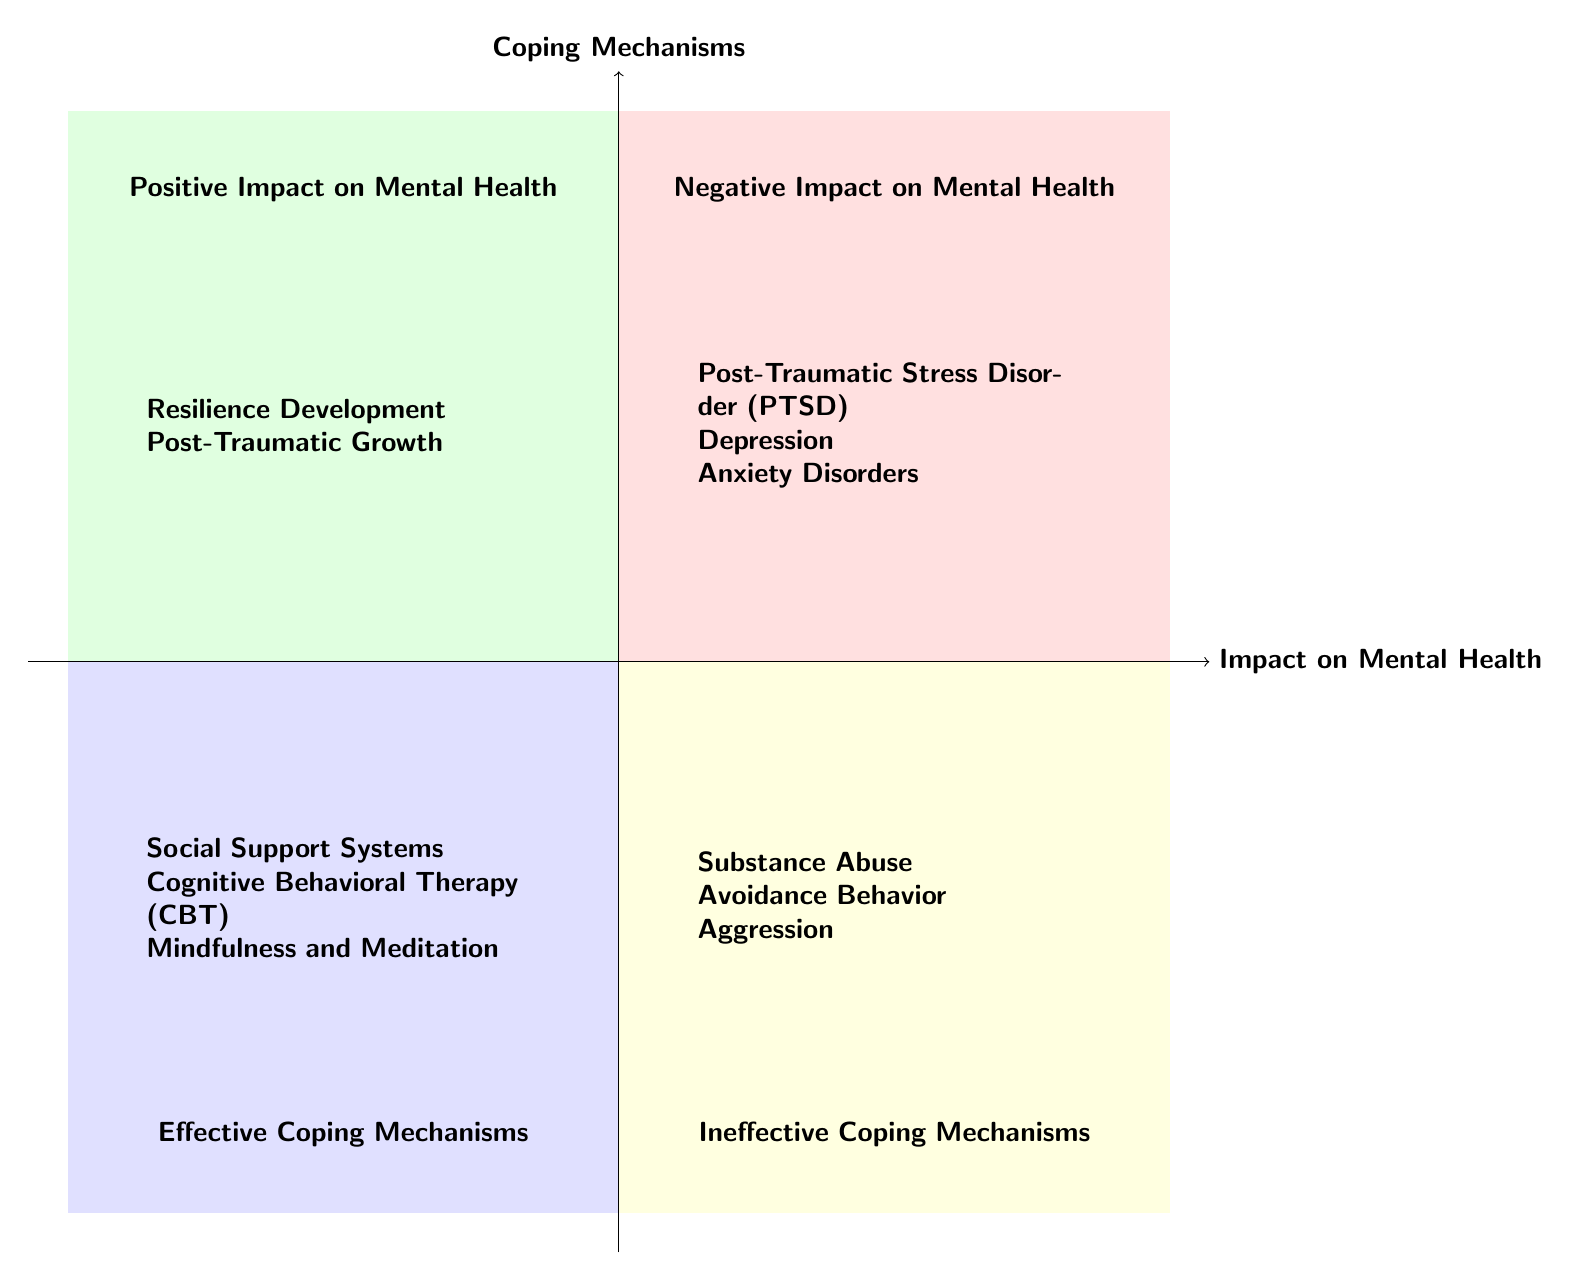What are the elements in the "Negative Impact on Mental Health" quadrant? The "Negative Impact on Mental Health" quadrant contains three elements: Post-Traumatic Stress Disorder (PTSD), Depression, and Anxiety Disorders. These can be directly identified in the quadrant as labeled items.
Answer: Post-Traumatic Stress Disorder (PTSD), Depression, Anxiety Disorders How many elements are in the "Effective Coping Mechanisms" quadrant? The "Effective Coping Mechanisms" quadrant includes three elements: Social Support Systems, Cognitive Behavioral Therapy (CBT), and Mindfulness and Meditation. By counting the items listed in this quadrant, we can confirm the total.
Answer: 3 What coping mechanism is considered ineffective and relates to substance use? The ineffective coping mechanism that relates to substance use is Substance Abuse. It is explicitly listed in the "Ineffective Coping Mechanisms" quadrant, indicating its classification.
Answer: Substance Abuse Which coping mechanism is associated with avoiding triggers? The coping mechanism associated with avoiding triggers is Avoidance Behavior. This element is detailed in the "Ineffective Coping Mechanisms" quadrant, representing a method of coping that leads to increased anxiety.
Answer: Avoidance Behavior Is "Post-Traumatic Growth" listed in the "Effective Coping Mechanisms" quadrant? No, "Post-Traumatic Growth" is not listed in the "Effective Coping Mechanisms" quadrant; instead, it appears in the "Positive Impact on Mental Health" quadrant. This can be verified by locating the item in the correct quadrant in the diagram.
Answer: No Which two factors contribute to negative impacts on mental health? The factors contributing to negative impacts on mental health include Post-Traumatic Stress Disorder (PTSD) and Depression. Both are identified in the "Negative Impact on Mental Health" quadrant, providing evidence of their effects.
Answer: Post-Traumatic Stress Disorder (PTSD), Depression What is the relationship between resilience and war in terms of mental health? The relationship is that resilience can develop as a positive impact on mental health due to exposure to war. This concept is outlined in the "Positive Impact on Mental Health" quadrant, describing how adversity can lead to resilience.
Answer: Resilience Development How many types of coping mechanisms are identified as effective? There are three types of coping mechanisms identified as effective: Social Support Systems, Cognitive Behavioral Therapy (CBT), and Mindfulness and Meditation. This information is gathered from enumerating the elements in the "Effective Coping Mechanisms" quadrant.
Answer: 3 